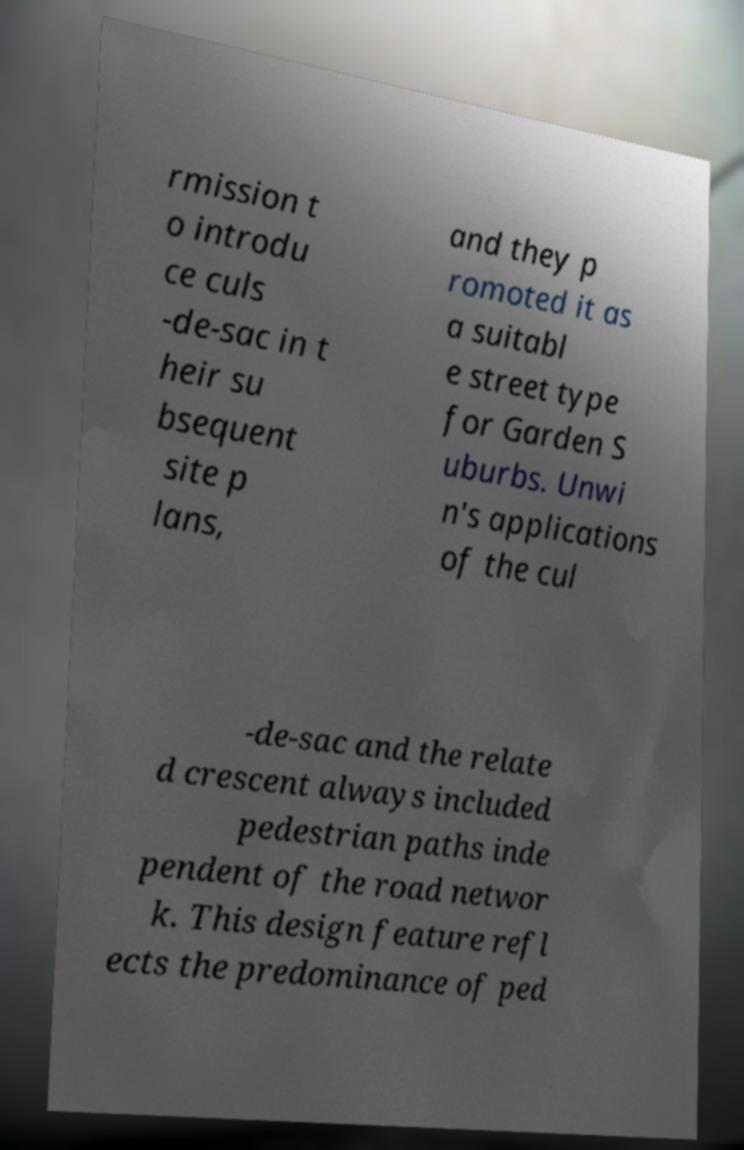Could you assist in decoding the text presented in this image and type it out clearly? rmission t o introdu ce culs -de-sac in t heir su bsequent site p lans, and they p romoted it as a suitabl e street type for Garden S uburbs. Unwi n's applications of the cul -de-sac and the relate d crescent always included pedestrian paths inde pendent of the road networ k. This design feature refl ects the predominance of ped 